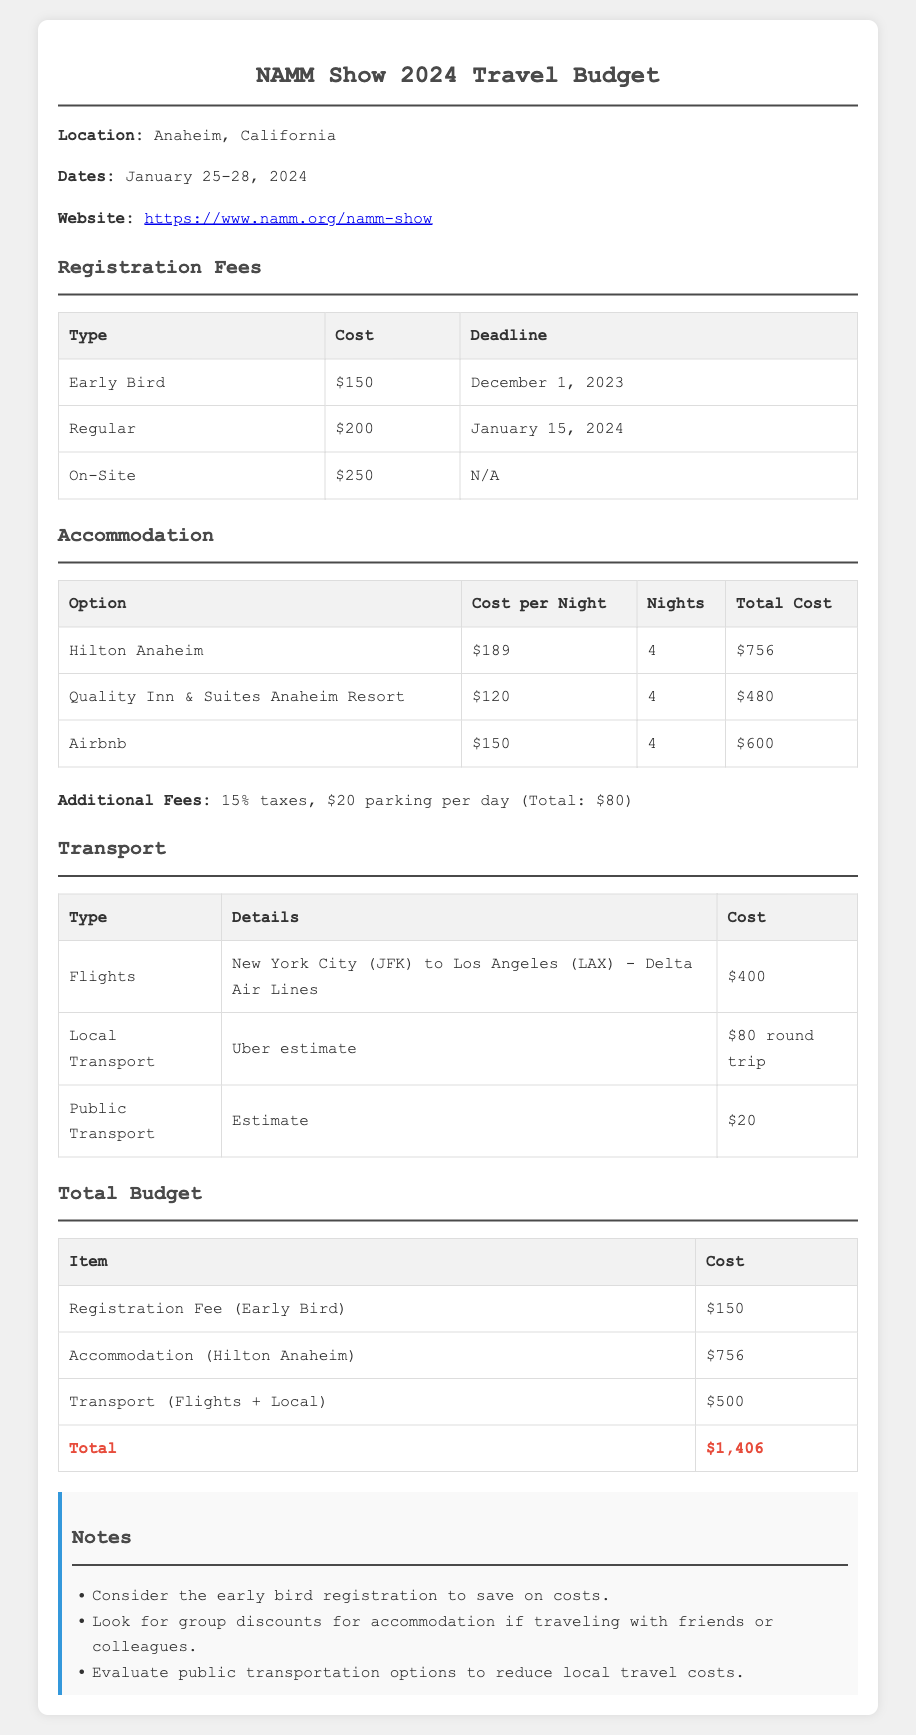What is the total cost for accommodation at Hilton Anaheim? The total cost for accommodation at Hilton Anaheim is calculated by multiplying the cost per night by the number of nights, which is $189 x 4 = $756.
Answer: $756 What is the early bird registration fee? The early bird registration fee listed in the document is $150.
Answer: $150 What is the total transport cost? The total transport cost includes flights and local transport, which sums up to $400 + $100 = $500.
Answer: $500 When is the deadline for regular registration? The document states that the deadline for regular registration is January 15, 2024.
Answer: January 15, 2024 Which accommodation option has the lowest cost? The lowest accommodation cost option listed is Quality Inn & Suites Anaheim Resort at $120 per night.
Answer: Quality Inn & Suites Anaheim Resort What is the total travel budget? The total travel budget is the sum of registration fees, accommodation, and transport costs, amounting to $1,406.
Answer: $1,406 How many nights will the composer be staying? The number of nights mentioned for accommodation is 4.
Answer: 4 What is the total cost of additional fees? Additional fees total 15% taxes plus $80 for parking, summing up to $80 for parking only (as taxes are not itemized).
Answer: $80 What transport option has the highest cost? The transport option with the highest cost is the flights at $400.
Answer: Flights 